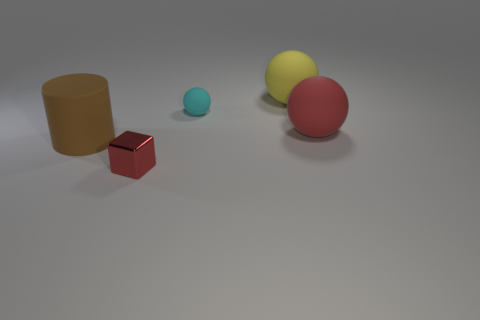Subtract all large rubber balls. How many balls are left? 1 Add 2 red metal things. How many objects exist? 7 Subtract 1 balls. How many balls are left? 2 Subtract all brown spheres. Subtract all gray cylinders. How many spheres are left? 3 Add 5 cyan spheres. How many cyan spheres are left? 6 Add 2 brown rubber objects. How many brown rubber objects exist? 3 Subtract 1 red spheres. How many objects are left? 4 Subtract all spheres. How many objects are left? 2 Subtract all small cubes. Subtract all small yellow spheres. How many objects are left? 4 